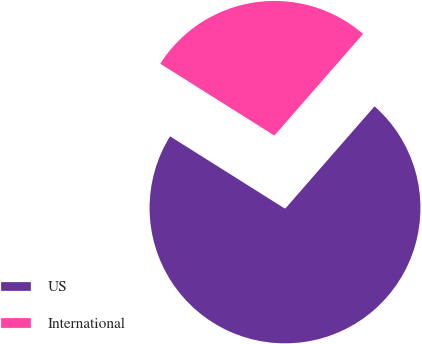Convert chart. <chart><loc_0><loc_0><loc_500><loc_500><pie_chart><fcel>US<fcel>International<nl><fcel>72.52%<fcel>27.48%<nl></chart> 